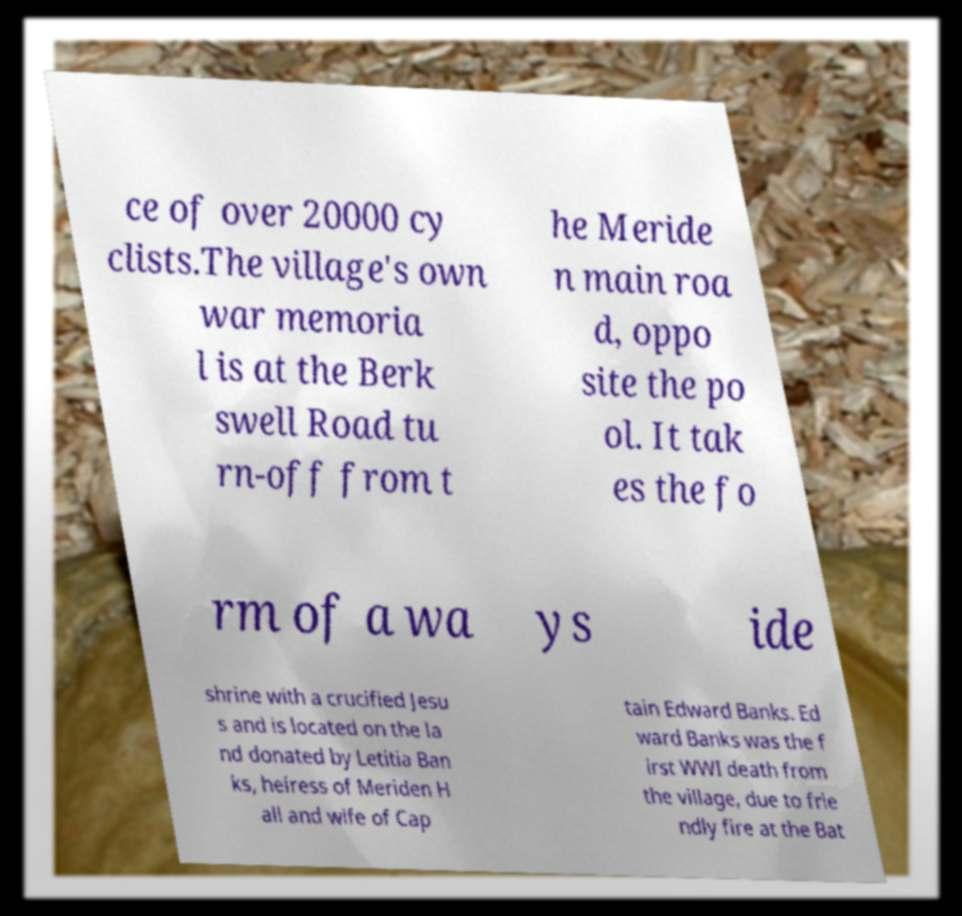Could you extract and type out the text from this image? ce of over 20000 cy clists.The village's own war memoria l is at the Berk swell Road tu rn-off from t he Meride n main roa d, oppo site the po ol. It tak es the fo rm of a wa ys ide shrine with a crucified Jesu s and is located on the la nd donated by Letitia Ban ks, heiress of Meriden H all and wife of Cap tain Edward Banks. Ed ward Banks was the f irst WWI death from the village, due to frie ndly fire at the Bat 